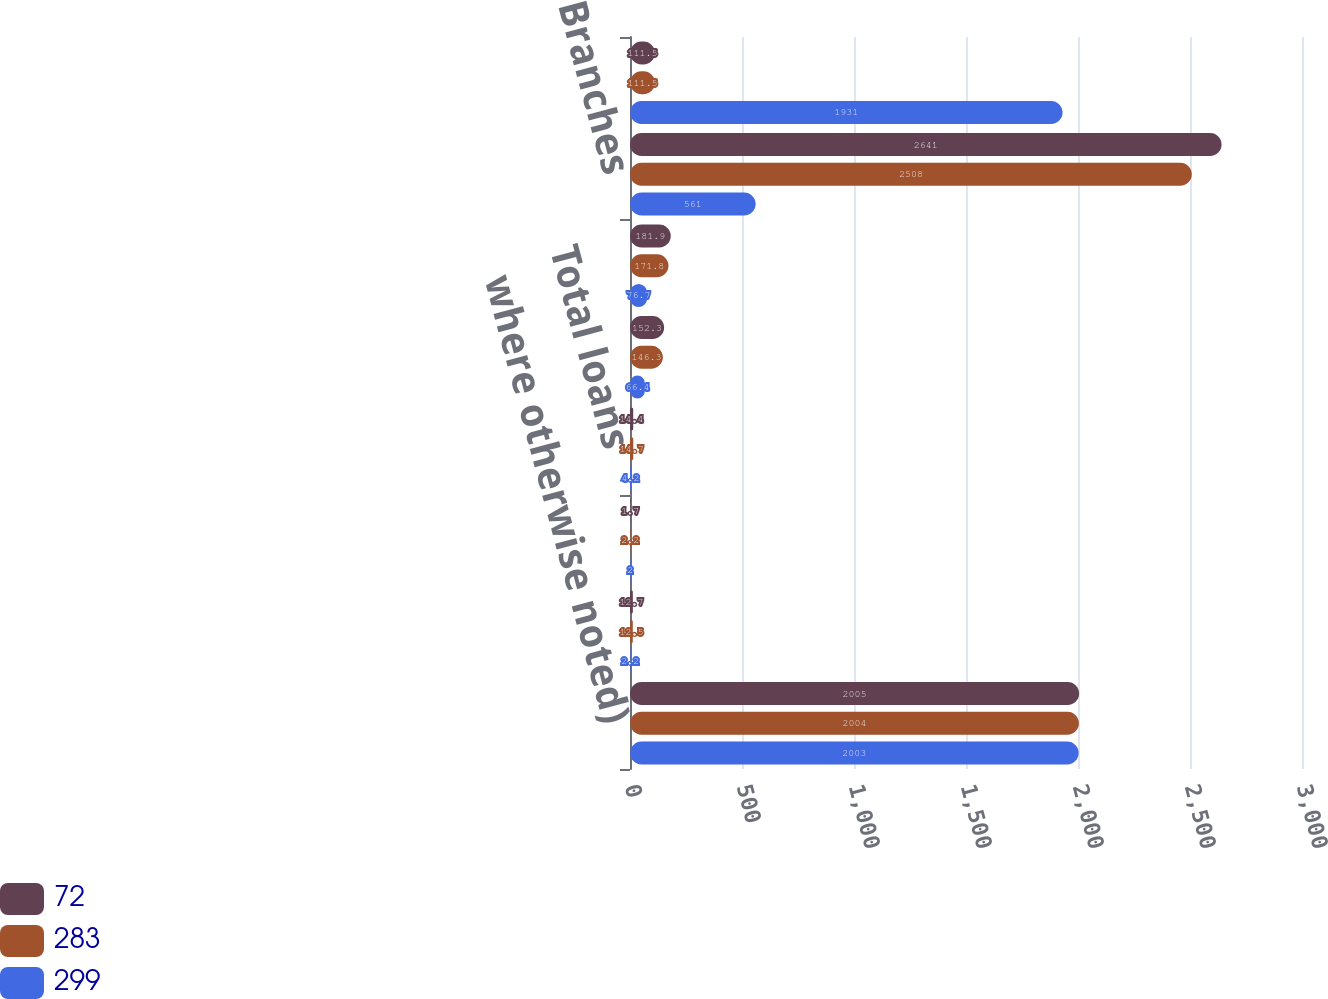Convert chart. <chart><loc_0><loc_0><loc_500><loc_500><stacked_bar_chart><ecel><fcel>where otherwise noted)<fcel>Small business loans<fcel>Consumer and other loans (b)<fcel>Total loans<fcel>Core deposits (c)<fcel>Total deposits<fcel>Branches<fcel>ATMs<nl><fcel>72<fcel>2005<fcel>12.7<fcel>1.7<fcel>14.4<fcel>152.3<fcel>181.9<fcel>2641<fcel>111.5<nl><fcel>283<fcel>2004<fcel>12.5<fcel>2.2<fcel>14.7<fcel>146.3<fcel>171.8<fcel>2508<fcel>111.5<nl><fcel>299<fcel>2003<fcel>2.2<fcel>2<fcel>4.2<fcel>66.4<fcel>76.7<fcel>561<fcel>1931<nl></chart> 